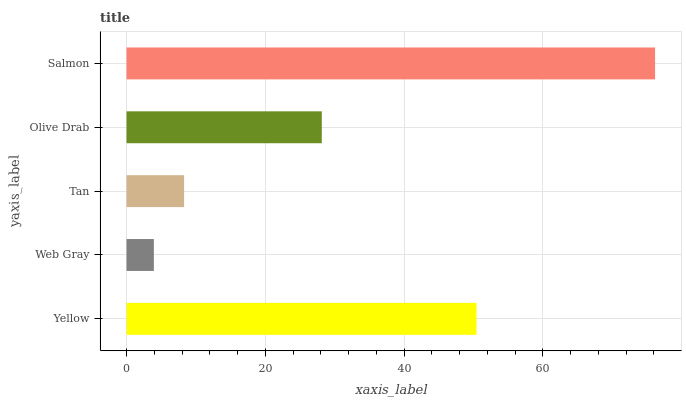Is Web Gray the minimum?
Answer yes or no. Yes. Is Salmon the maximum?
Answer yes or no. Yes. Is Tan the minimum?
Answer yes or no. No. Is Tan the maximum?
Answer yes or no. No. Is Tan greater than Web Gray?
Answer yes or no. Yes. Is Web Gray less than Tan?
Answer yes or no. Yes. Is Web Gray greater than Tan?
Answer yes or no. No. Is Tan less than Web Gray?
Answer yes or no. No. Is Olive Drab the high median?
Answer yes or no. Yes. Is Olive Drab the low median?
Answer yes or no. Yes. Is Salmon the high median?
Answer yes or no. No. Is Salmon the low median?
Answer yes or no. No. 